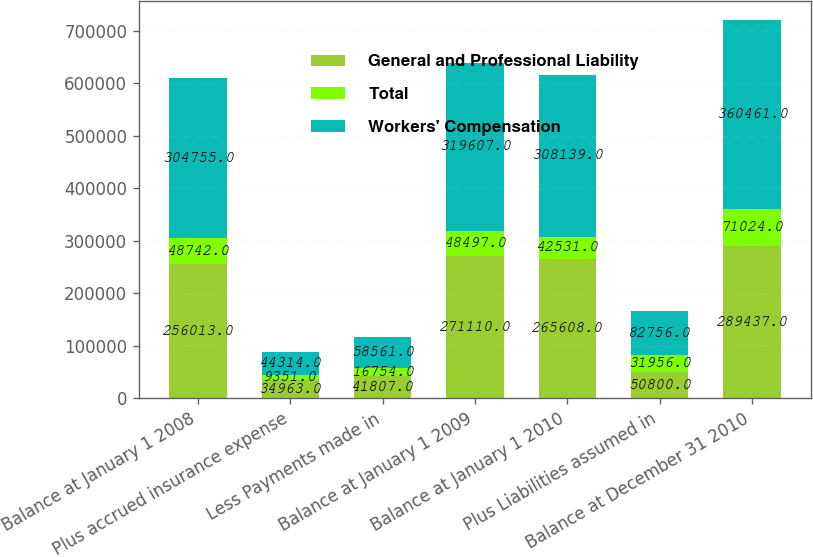Convert chart to OTSL. <chart><loc_0><loc_0><loc_500><loc_500><stacked_bar_chart><ecel><fcel>Balance at January 1 2008<fcel>Plus accrued insurance expense<fcel>Less Payments made in<fcel>Balance at January 1 2009<fcel>Balance at January 1 2010<fcel>Plus Liabilities assumed in<fcel>Balance at December 31 2010<nl><fcel>General and Professional Liability<fcel>256013<fcel>34963<fcel>41807<fcel>271110<fcel>265608<fcel>50800<fcel>289437<nl><fcel>Total<fcel>48742<fcel>9351<fcel>16754<fcel>48497<fcel>42531<fcel>31956<fcel>71024<nl><fcel>Workers' Compensation<fcel>304755<fcel>44314<fcel>58561<fcel>319607<fcel>308139<fcel>82756<fcel>360461<nl></chart> 